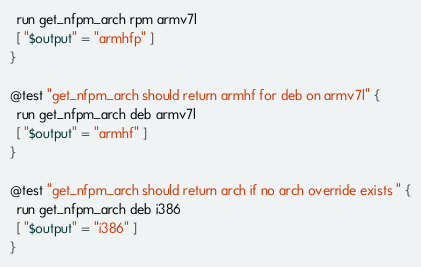Convert code to text. <code><loc_0><loc_0><loc_500><loc_500><_Bash_>  run get_nfpm_arch rpm armv7l
  [ "$output" = "armhfp" ]
}

@test "get_nfpm_arch should return armhf for deb on armv7l" {
  run get_nfpm_arch deb armv7l
  [ "$output" = "armhf" ]
}

@test "get_nfpm_arch should return arch if no arch override exists " {
  run get_nfpm_arch deb i386
  [ "$output" = "i386" ]
}</code> 